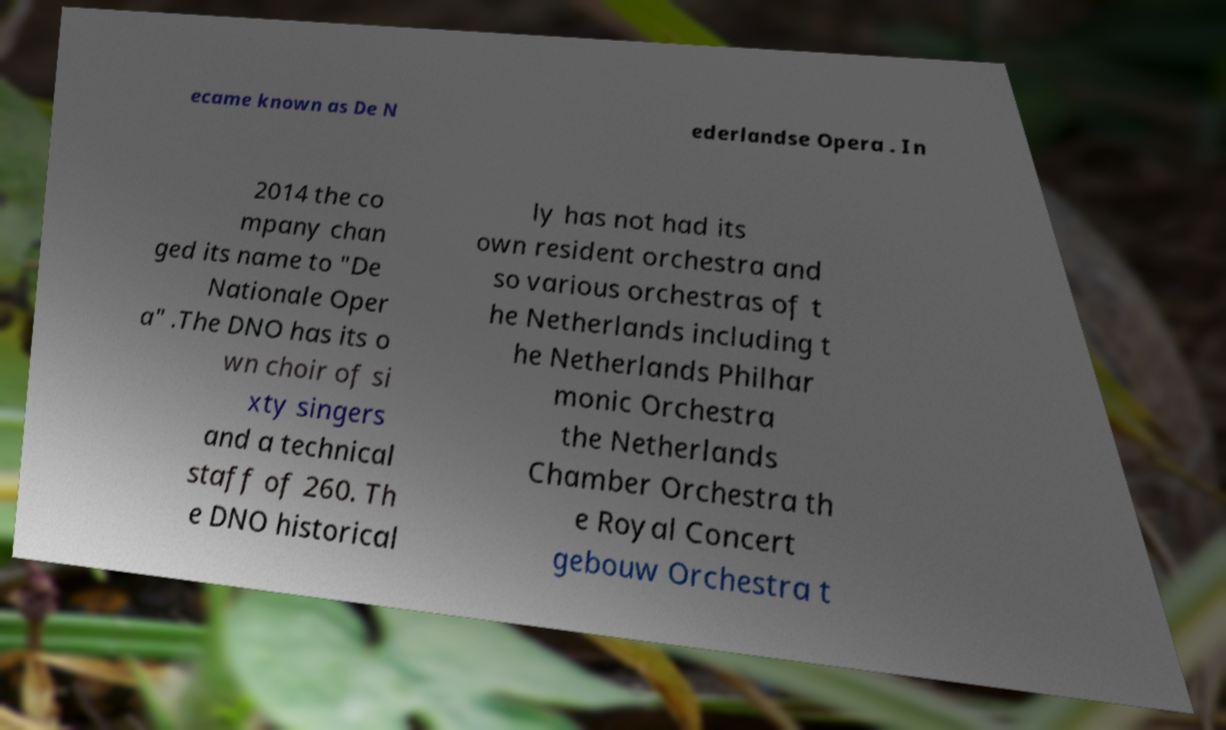Can you accurately transcribe the text from the provided image for me? ecame known as De N ederlandse Opera . In 2014 the co mpany chan ged its name to "De Nationale Oper a" .The DNO has its o wn choir of si xty singers and a technical staff of 260. Th e DNO historical ly has not had its own resident orchestra and so various orchestras of t he Netherlands including t he Netherlands Philhar monic Orchestra the Netherlands Chamber Orchestra th e Royal Concert gebouw Orchestra t 